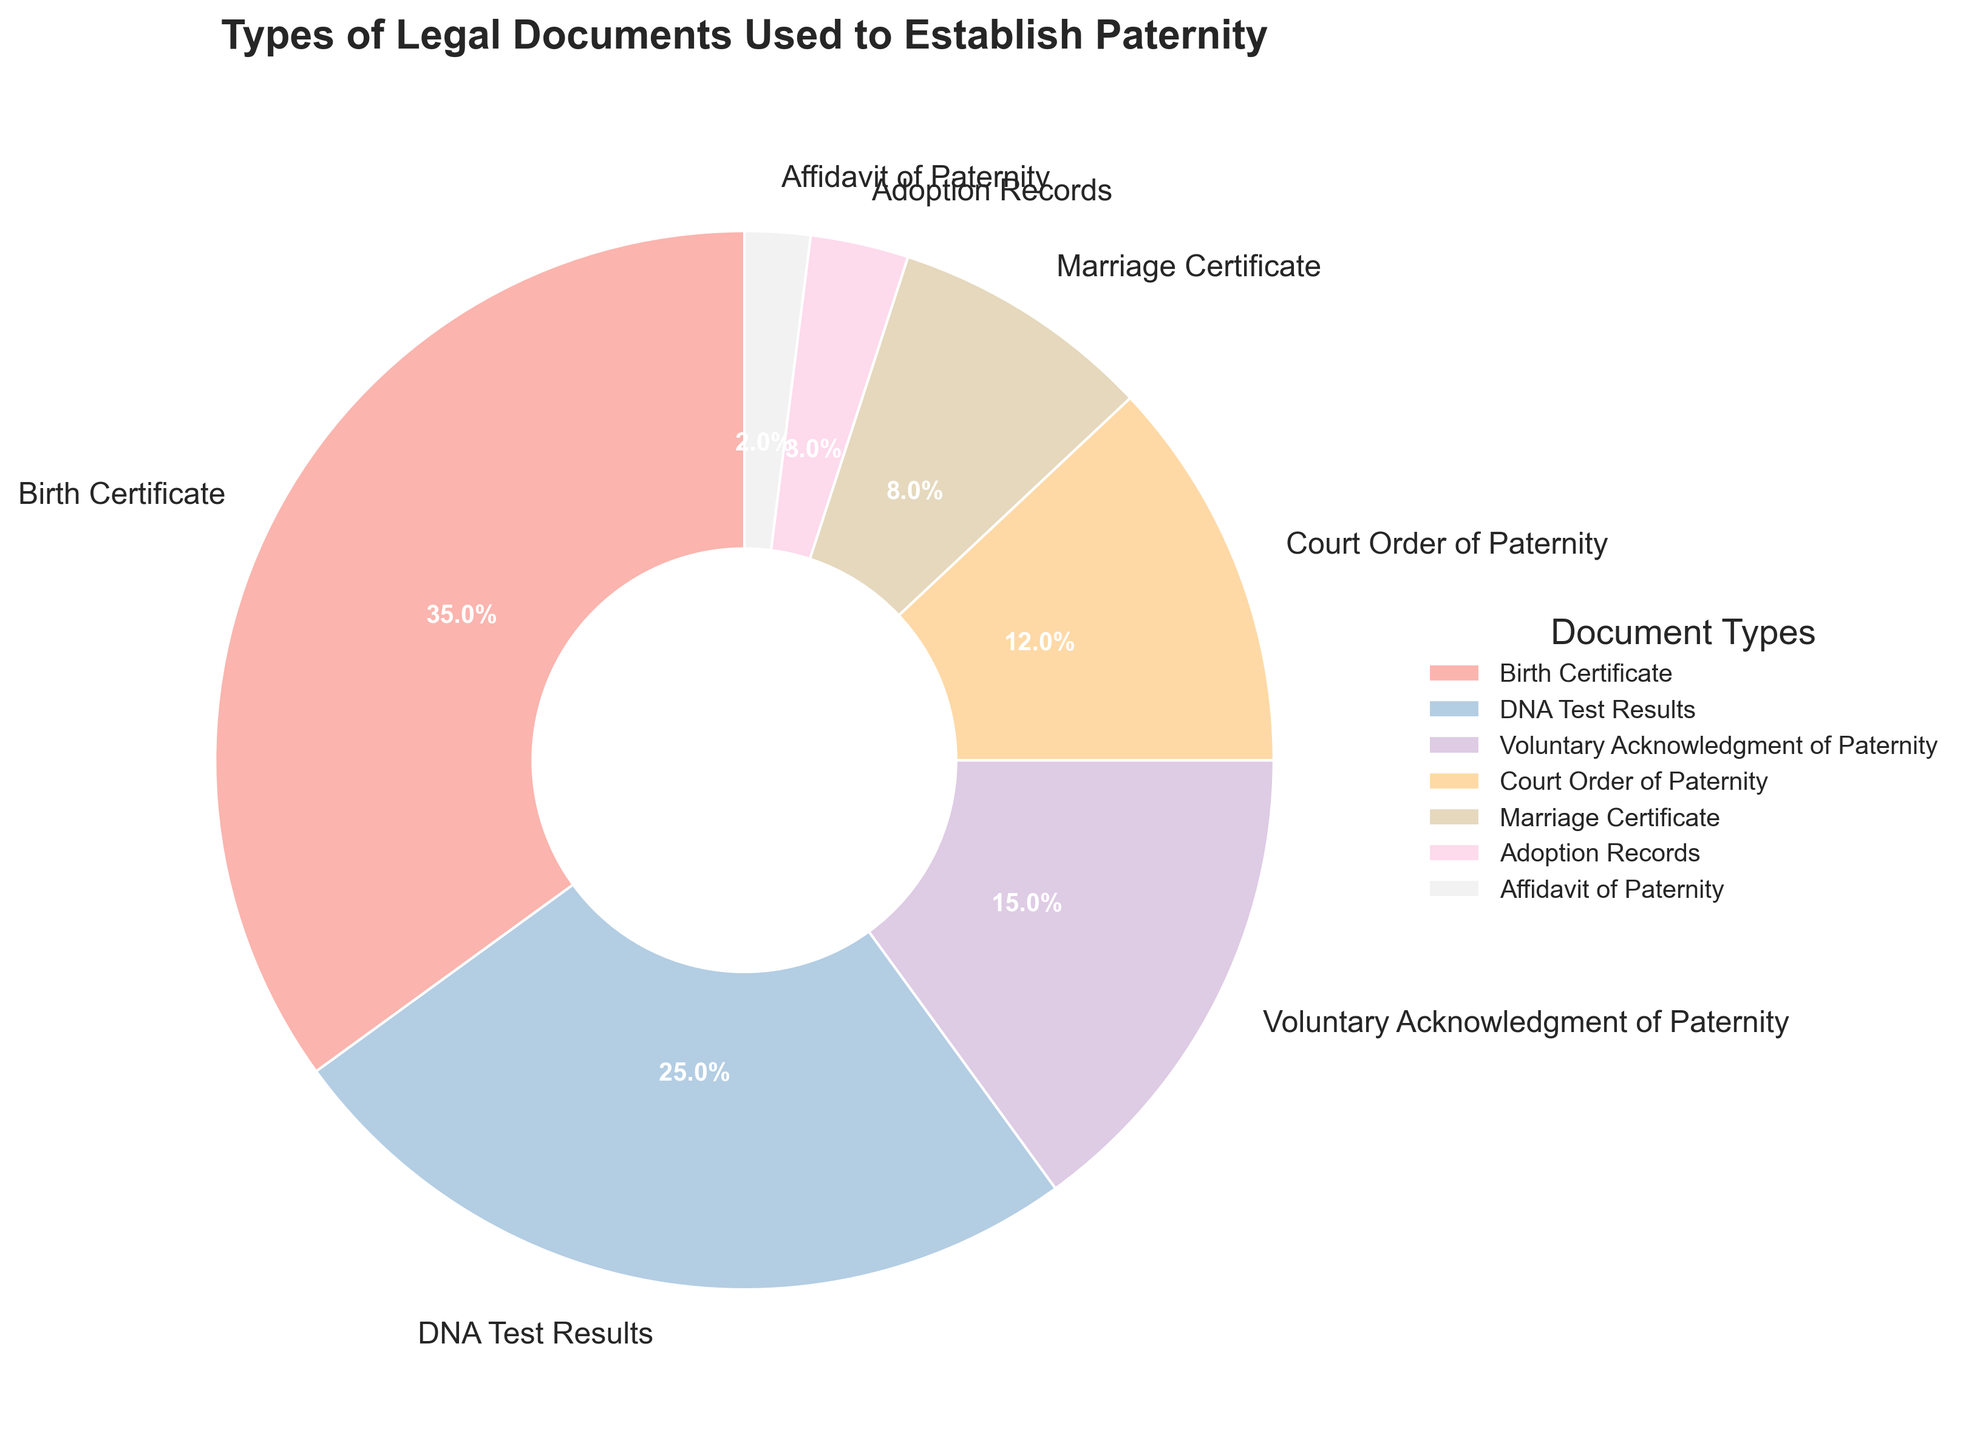Which document type is most commonly used to establish paternity? The segment with the largest percentage represents the most commonly used document. Here, it's the Birth Certificate with a 35% share.
Answer: Birth Certificate What is the combined percentage of Court Orders of Paternity and Adoption Records? The percentages for Court Order of Paternity and Adoption Records are 12% and 3%, respectively. Adding these together: 12% + 3% = 15%.
Answer: 15% How does the percentage of DNA Test Results compare to the percentage of Voluntary Acknowledgment of Paternity? The percentage of DNA Test Results is 25%, while the percentage of Voluntary Acknowledgment of Paternity is 15%. Since 25% is greater than 15%, DNA Test Results have a higher percentage.
Answer: DNA Test Results have a higher percentage Which document type has the smallest share? The segment with the smallest percentage represents the document with the smallest share. Here, it's the Affidavit of Paternity with a 2% share.
Answer: Affidavit of Paternity What is the difference between the percentage of Birth Certificates and Marriage Certificates? The Birth Certificates' share is 35%, and the Marriage Certificates' share is 8%. The difference is 35% - 8% = 27%.
Answer: 27% How many document types have a percentage greater than 10%? By observing the segments, we see that Birth Certificates (35%), DNA Test Results (25%), Voluntary Acknowledgment of Paternity (15%), and Court Order of Paternity (12%) all have percentages greater than 10%. That makes four document types.
Answer: 4 What percentage of the pie chart is not covered by DNA Test Results? DNA Test Results cover 25% of the pie chart. Hence, the remaining percentage is 100% - 25% = 75%.
Answer: 75% If Birth Certificates and DNA Test Results are combined into one category, what would be their total percentage? Adding the percentages of Birth Certificates (35%) and DNA Test Results (25%) together: 35% + 25% = 60%.
Answer: 60% Which document type is visually represented by a relatively small, light-colored segment? The pie chart's color scheme would show a small, light-colored segment, which corresponds to one of the least common document types. Here, the Affidavit of Paternity (2%) fits this description.
Answer: Affidavit of Paternity What is the average percentage of the three least common document types? The three least common document types (Affidavit of Paternity, Adoption Records, and Marriage Certificate) have percentages of 2%, 3%, and 8%, respectively. Their average is calculated as (2% + 3% + 8%) / 3 = 4.33%.
Answer: 4.33% 